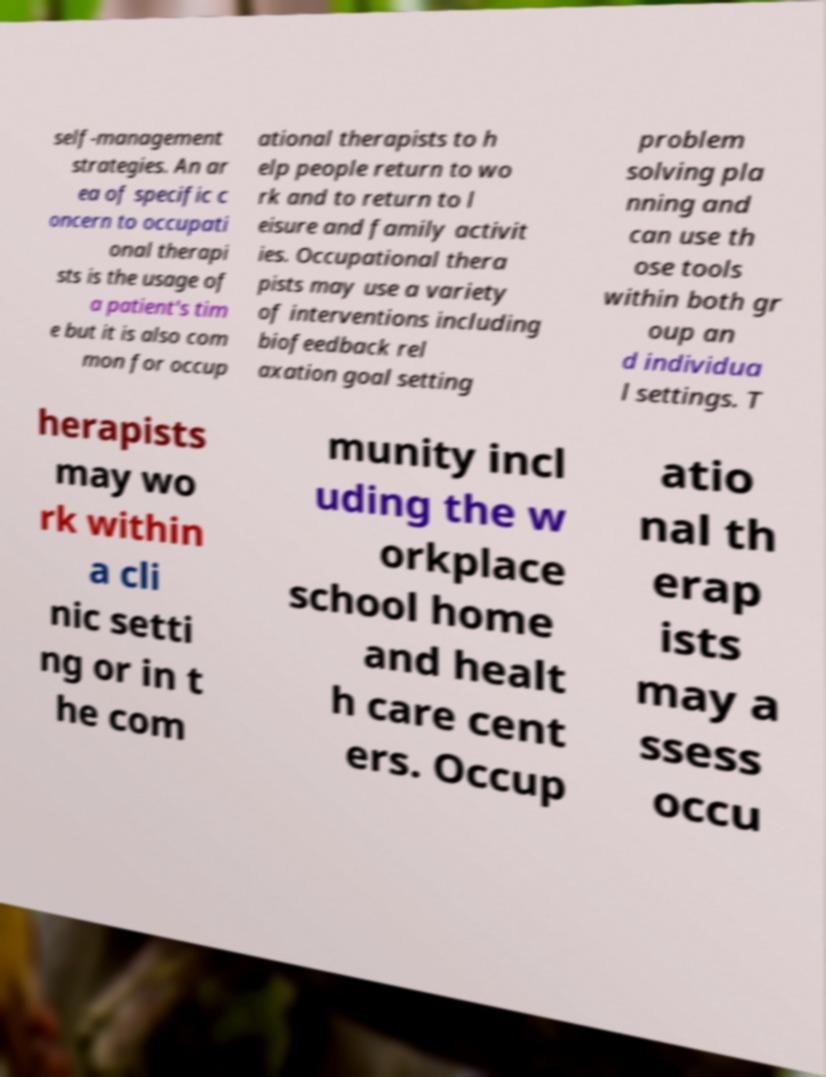There's text embedded in this image that I need extracted. Can you transcribe it verbatim? self-management strategies. An ar ea of specific c oncern to occupati onal therapi sts is the usage of a patient's tim e but it is also com mon for occup ational therapists to h elp people return to wo rk and to return to l eisure and family activit ies. Occupational thera pists may use a variety of interventions including biofeedback rel axation goal setting problem solving pla nning and can use th ose tools within both gr oup an d individua l settings. T herapists may wo rk within a cli nic setti ng or in t he com munity incl uding the w orkplace school home and healt h care cent ers. Occup atio nal th erap ists may a ssess occu 